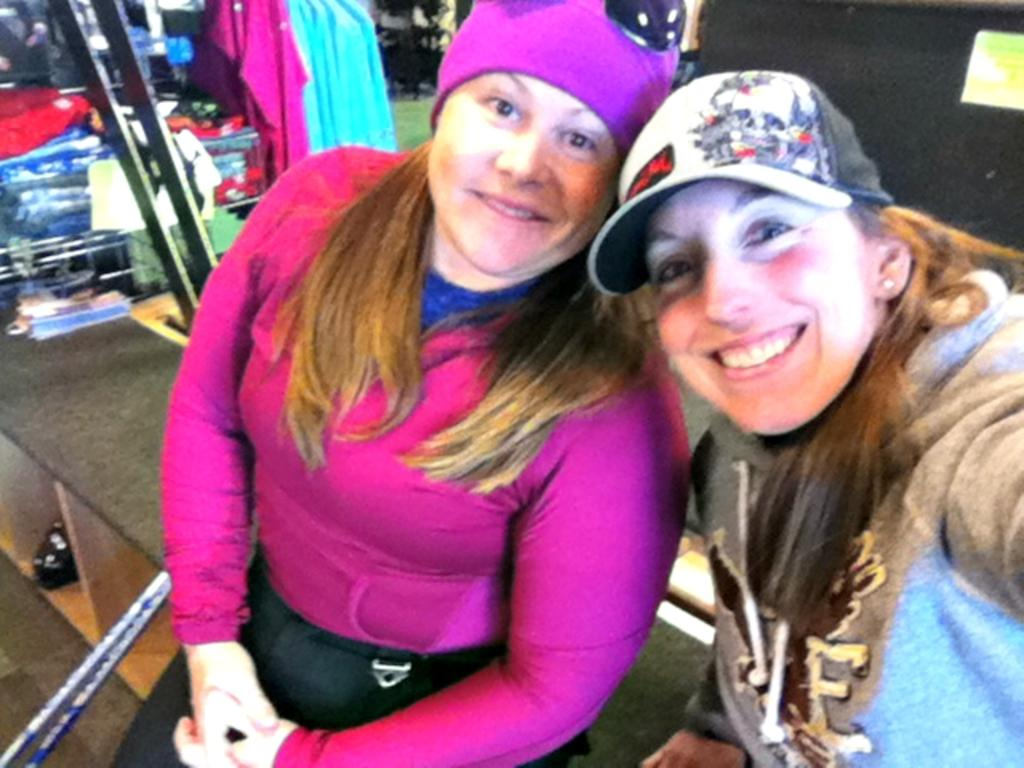How many people are in the image? There are two women in the image. What are the women doing in the image? The women are sitting on an object. What can be seen behind the women? There are clothes and other objects visible behind the women. Is there a boy holding a bat in the image? No, there is no boy or bat present in the image. 